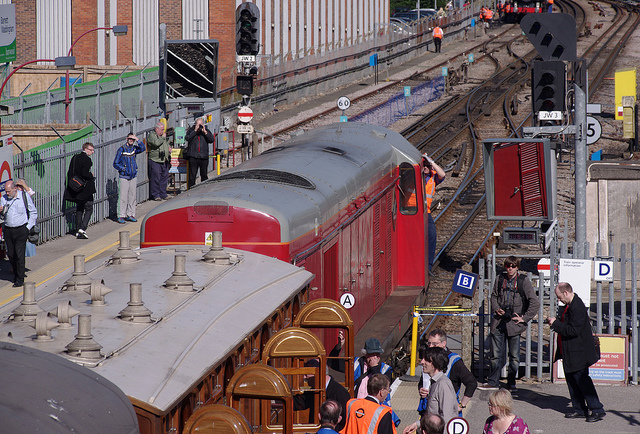<image>Is this train brand new? It is unknown if the train is brand new. Most answers suggest that it is not. Is this train brand new? I don't know if the train is brand new. It doesn't seem to be. 